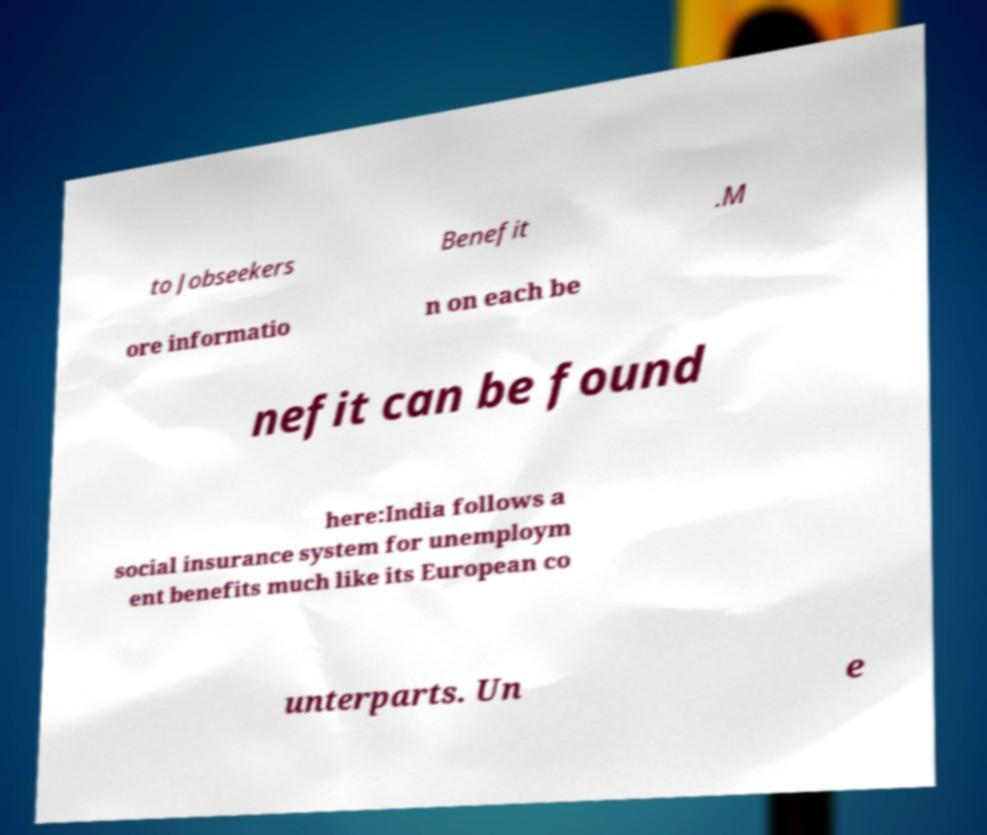Please read and relay the text visible in this image. What does it say? to Jobseekers Benefit .M ore informatio n on each be nefit can be found here:India follows a social insurance system for unemploym ent benefits much like its European co unterparts. Un e 